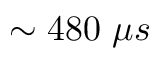<formula> <loc_0><loc_0><loc_500><loc_500>\sim 4 8 0 \ \mu s</formula> 